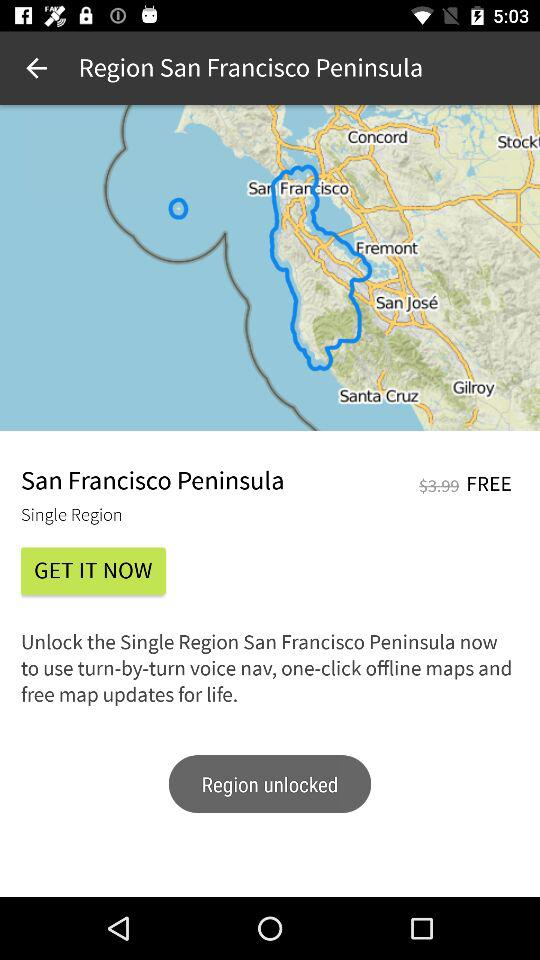How much is the difference in price between the Single Region San Francisco Peninsula and the FREE option?
Answer the question using a single word or phrase. $3.99 